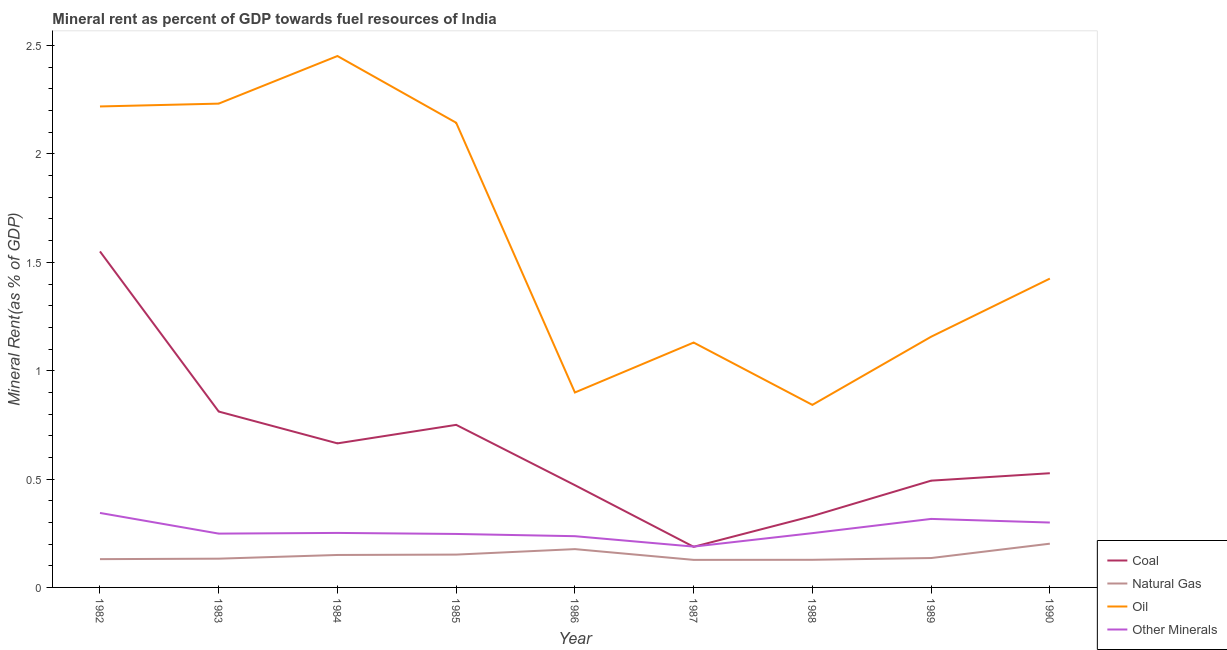How many different coloured lines are there?
Offer a terse response. 4. Is the number of lines equal to the number of legend labels?
Your answer should be compact. Yes. What is the coal rent in 1989?
Provide a short and direct response. 0.49. Across all years, what is the maximum coal rent?
Keep it short and to the point. 1.55. Across all years, what is the minimum coal rent?
Your answer should be compact. 0.19. In which year was the natural gas rent maximum?
Offer a terse response. 1990. In which year was the natural gas rent minimum?
Your answer should be very brief. 1987. What is the total  rent of other minerals in the graph?
Keep it short and to the point. 2.38. What is the difference between the oil rent in 1988 and that in 1989?
Ensure brevity in your answer.  -0.31. What is the difference between the  rent of other minerals in 1985 and the natural gas rent in 1986?
Offer a very short reply. 0.07. What is the average oil rent per year?
Provide a short and direct response. 1.61. In the year 1988, what is the difference between the natural gas rent and  rent of other minerals?
Your response must be concise. -0.12. What is the ratio of the  rent of other minerals in 1986 to that in 1988?
Your answer should be very brief. 0.94. What is the difference between the highest and the second highest oil rent?
Ensure brevity in your answer.  0.22. What is the difference between the highest and the lowest coal rent?
Offer a very short reply. 1.36. In how many years, is the natural gas rent greater than the average natural gas rent taken over all years?
Offer a terse response. 4. Is it the case that in every year, the sum of the  rent of other minerals and oil rent is greater than the sum of coal rent and natural gas rent?
Your answer should be very brief. Yes. Is it the case that in every year, the sum of the coal rent and natural gas rent is greater than the oil rent?
Your answer should be very brief. No. Does the  rent of other minerals monotonically increase over the years?
Your answer should be very brief. No. Is the oil rent strictly greater than the natural gas rent over the years?
Offer a terse response. Yes. Is the natural gas rent strictly less than the coal rent over the years?
Give a very brief answer. Yes. How many lines are there?
Give a very brief answer. 4. Are the values on the major ticks of Y-axis written in scientific E-notation?
Keep it short and to the point. No. How many legend labels are there?
Offer a very short reply. 4. How are the legend labels stacked?
Make the answer very short. Vertical. What is the title of the graph?
Make the answer very short. Mineral rent as percent of GDP towards fuel resources of India. Does "Social Insurance" appear as one of the legend labels in the graph?
Provide a succinct answer. No. What is the label or title of the X-axis?
Provide a succinct answer. Year. What is the label or title of the Y-axis?
Give a very brief answer. Mineral Rent(as % of GDP). What is the Mineral Rent(as % of GDP) in Coal in 1982?
Provide a succinct answer. 1.55. What is the Mineral Rent(as % of GDP) of Natural Gas in 1982?
Your answer should be compact. 0.13. What is the Mineral Rent(as % of GDP) of Oil in 1982?
Your answer should be compact. 2.22. What is the Mineral Rent(as % of GDP) in Other Minerals in 1982?
Provide a succinct answer. 0.34. What is the Mineral Rent(as % of GDP) of Coal in 1983?
Your response must be concise. 0.81. What is the Mineral Rent(as % of GDP) in Natural Gas in 1983?
Your response must be concise. 0.13. What is the Mineral Rent(as % of GDP) of Oil in 1983?
Your response must be concise. 2.23. What is the Mineral Rent(as % of GDP) of Other Minerals in 1983?
Give a very brief answer. 0.25. What is the Mineral Rent(as % of GDP) of Coal in 1984?
Ensure brevity in your answer.  0.66. What is the Mineral Rent(as % of GDP) of Natural Gas in 1984?
Provide a short and direct response. 0.15. What is the Mineral Rent(as % of GDP) in Oil in 1984?
Your answer should be compact. 2.45. What is the Mineral Rent(as % of GDP) in Other Minerals in 1984?
Provide a short and direct response. 0.25. What is the Mineral Rent(as % of GDP) of Coal in 1985?
Your response must be concise. 0.75. What is the Mineral Rent(as % of GDP) in Natural Gas in 1985?
Ensure brevity in your answer.  0.15. What is the Mineral Rent(as % of GDP) of Oil in 1985?
Provide a succinct answer. 2.14. What is the Mineral Rent(as % of GDP) in Other Minerals in 1985?
Make the answer very short. 0.25. What is the Mineral Rent(as % of GDP) in Coal in 1986?
Provide a short and direct response. 0.47. What is the Mineral Rent(as % of GDP) of Natural Gas in 1986?
Your response must be concise. 0.18. What is the Mineral Rent(as % of GDP) of Oil in 1986?
Provide a succinct answer. 0.9. What is the Mineral Rent(as % of GDP) in Other Minerals in 1986?
Give a very brief answer. 0.24. What is the Mineral Rent(as % of GDP) of Coal in 1987?
Keep it short and to the point. 0.19. What is the Mineral Rent(as % of GDP) of Natural Gas in 1987?
Provide a short and direct response. 0.13. What is the Mineral Rent(as % of GDP) in Oil in 1987?
Offer a terse response. 1.13. What is the Mineral Rent(as % of GDP) in Other Minerals in 1987?
Make the answer very short. 0.19. What is the Mineral Rent(as % of GDP) in Coal in 1988?
Offer a terse response. 0.33. What is the Mineral Rent(as % of GDP) in Natural Gas in 1988?
Provide a succinct answer. 0.13. What is the Mineral Rent(as % of GDP) in Oil in 1988?
Your answer should be compact. 0.84. What is the Mineral Rent(as % of GDP) in Other Minerals in 1988?
Offer a very short reply. 0.25. What is the Mineral Rent(as % of GDP) of Coal in 1989?
Ensure brevity in your answer.  0.49. What is the Mineral Rent(as % of GDP) of Natural Gas in 1989?
Give a very brief answer. 0.14. What is the Mineral Rent(as % of GDP) of Oil in 1989?
Your answer should be compact. 1.16. What is the Mineral Rent(as % of GDP) of Other Minerals in 1989?
Your answer should be compact. 0.32. What is the Mineral Rent(as % of GDP) of Coal in 1990?
Give a very brief answer. 0.53. What is the Mineral Rent(as % of GDP) of Natural Gas in 1990?
Provide a succinct answer. 0.2. What is the Mineral Rent(as % of GDP) in Oil in 1990?
Ensure brevity in your answer.  1.42. What is the Mineral Rent(as % of GDP) of Other Minerals in 1990?
Provide a succinct answer. 0.3. Across all years, what is the maximum Mineral Rent(as % of GDP) of Coal?
Offer a very short reply. 1.55. Across all years, what is the maximum Mineral Rent(as % of GDP) in Natural Gas?
Offer a terse response. 0.2. Across all years, what is the maximum Mineral Rent(as % of GDP) in Oil?
Offer a terse response. 2.45. Across all years, what is the maximum Mineral Rent(as % of GDP) in Other Minerals?
Ensure brevity in your answer.  0.34. Across all years, what is the minimum Mineral Rent(as % of GDP) of Coal?
Your answer should be very brief. 0.19. Across all years, what is the minimum Mineral Rent(as % of GDP) in Natural Gas?
Give a very brief answer. 0.13. Across all years, what is the minimum Mineral Rent(as % of GDP) of Oil?
Provide a succinct answer. 0.84. Across all years, what is the minimum Mineral Rent(as % of GDP) in Other Minerals?
Offer a terse response. 0.19. What is the total Mineral Rent(as % of GDP) in Coal in the graph?
Your answer should be very brief. 5.78. What is the total Mineral Rent(as % of GDP) in Natural Gas in the graph?
Provide a short and direct response. 1.33. What is the total Mineral Rent(as % of GDP) of Oil in the graph?
Ensure brevity in your answer.  14.5. What is the total Mineral Rent(as % of GDP) in Other Minerals in the graph?
Your response must be concise. 2.38. What is the difference between the Mineral Rent(as % of GDP) of Coal in 1982 and that in 1983?
Provide a succinct answer. 0.74. What is the difference between the Mineral Rent(as % of GDP) in Natural Gas in 1982 and that in 1983?
Your answer should be very brief. -0. What is the difference between the Mineral Rent(as % of GDP) in Oil in 1982 and that in 1983?
Your answer should be very brief. -0.01. What is the difference between the Mineral Rent(as % of GDP) in Other Minerals in 1982 and that in 1983?
Give a very brief answer. 0.1. What is the difference between the Mineral Rent(as % of GDP) of Coal in 1982 and that in 1984?
Provide a short and direct response. 0.89. What is the difference between the Mineral Rent(as % of GDP) in Natural Gas in 1982 and that in 1984?
Offer a very short reply. -0.02. What is the difference between the Mineral Rent(as % of GDP) of Oil in 1982 and that in 1984?
Provide a succinct answer. -0.23. What is the difference between the Mineral Rent(as % of GDP) in Other Minerals in 1982 and that in 1984?
Offer a very short reply. 0.09. What is the difference between the Mineral Rent(as % of GDP) of Coal in 1982 and that in 1985?
Provide a short and direct response. 0.8. What is the difference between the Mineral Rent(as % of GDP) of Natural Gas in 1982 and that in 1985?
Ensure brevity in your answer.  -0.02. What is the difference between the Mineral Rent(as % of GDP) in Oil in 1982 and that in 1985?
Offer a terse response. 0.08. What is the difference between the Mineral Rent(as % of GDP) of Other Minerals in 1982 and that in 1985?
Give a very brief answer. 0.1. What is the difference between the Mineral Rent(as % of GDP) in Coal in 1982 and that in 1986?
Keep it short and to the point. 1.08. What is the difference between the Mineral Rent(as % of GDP) of Natural Gas in 1982 and that in 1986?
Ensure brevity in your answer.  -0.05. What is the difference between the Mineral Rent(as % of GDP) of Oil in 1982 and that in 1986?
Make the answer very short. 1.32. What is the difference between the Mineral Rent(as % of GDP) of Other Minerals in 1982 and that in 1986?
Ensure brevity in your answer.  0.11. What is the difference between the Mineral Rent(as % of GDP) of Coal in 1982 and that in 1987?
Your answer should be compact. 1.36. What is the difference between the Mineral Rent(as % of GDP) in Natural Gas in 1982 and that in 1987?
Keep it short and to the point. 0. What is the difference between the Mineral Rent(as % of GDP) of Oil in 1982 and that in 1987?
Make the answer very short. 1.09. What is the difference between the Mineral Rent(as % of GDP) in Other Minerals in 1982 and that in 1987?
Your response must be concise. 0.16. What is the difference between the Mineral Rent(as % of GDP) in Coal in 1982 and that in 1988?
Make the answer very short. 1.22. What is the difference between the Mineral Rent(as % of GDP) of Natural Gas in 1982 and that in 1988?
Give a very brief answer. 0. What is the difference between the Mineral Rent(as % of GDP) in Oil in 1982 and that in 1988?
Your answer should be compact. 1.38. What is the difference between the Mineral Rent(as % of GDP) in Other Minerals in 1982 and that in 1988?
Offer a very short reply. 0.09. What is the difference between the Mineral Rent(as % of GDP) in Coal in 1982 and that in 1989?
Your answer should be compact. 1.06. What is the difference between the Mineral Rent(as % of GDP) in Natural Gas in 1982 and that in 1989?
Ensure brevity in your answer.  -0.01. What is the difference between the Mineral Rent(as % of GDP) in Oil in 1982 and that in 1989?
Provide a short and direct response. 1.06. What is the difference between the Mineral Rent(as % of GDP) in Other Minerals in 1982 and that in 1989?
Offer a very short reply. 0.03. What is the difference between the Mineral Rent(as % of GDP) of Coal in 1982 and that in 1990?
Make the answer very short. 1.02. What is the difference between the Mineral Rent(as % of GDP) of Natural Gas in 1982 and that in 1990?
Your response must be concise. -0.07. What is the difference between the Mineral Rent(as % of GDP) in Oil in 1982 and that in 1990?
Give a very brief answer. 0.79. What is the difference between the Mineral Rent(as % of GDP) in Other Minerals in 1982 and that in 1990?
Offer a very short reply. 0.04. What is the difference between the Mineral Rent(as % of GDP) of Coal in 1983 and that in 1984?
Give a very brief answer. 0.15. What is the difference between the Mineral Rent(as % of GDP) of Natural Gas in 1983 and that in 1984?
Provide a succinct answer. -0.02. What is the difference between the Mineral Rent(as % of GDP) in Oil in 1983 and that in 1984?
Your response must be concise. -0.22. What is the difference between the Mineral Rent(as % of GDP) of Other Minerals in 1983 and that in 1984?
Your answer should be very brief. -0. What is the difference between the Mineral Rent(as % of GDP) in Coal in 1983 and that in 1985?
Keep it short and to the point. 0.06. What is the difference between the Mineral Rent(as % of GDP) of Natural Gas in 1983 and that in 1985?
Your answer should be very brief. -0.02. What is the difference between the Mineral Rent(as % of GDP) of Oil in 1983 and that in 1985?
Ensure brevity in your answer.  0.09. What is the difference between the Mineral Rent(as % of GDP) in Other Minerals in 1983 and that in 1985?
Provide a succinct answer. 0. What is the difference between the Mineral Rent(as % of GDP) in Coal in 1983 and that in 1986?
Your answer should be very brief. 0.34. What is the difference between the Mineral Rent(as % of GDP) of Natural Gas in 1983 and that in 1986?
Provide a succinct answer. -0.04. What is the difference between the Mineral Rent(as % of GDP) of Oil in 1983 and that in 1986?
Your response must be concise. 1.33. What is the difference between the Mineral Rent(as % of GDP) in Other Minerals in 1983 and that in 1986?
Make the answer very short. 0.01. What is the difference between the Mineral Rent(as % of GDP) of Coal in 1983 and that in 1987?
Your response must be concise. 0.62. What is the difference between the Mineral Rent(as % of GDP) of Natural Gas in 1983 and that in 1987?
Provide a succinct answer. 0.01. What is the difference between the Mineral Rent(as % of GDP) of Oil in 1983 and that in 1987?
Offer a terse response. 1.1. What is the difference between the Mineral Rent(as % of GDP) of Other Minerals in 1983 and that in 1987?
Your answer should be compact. 0.06. What is the difference between the Mineral Rent(as % of GDP) of Coal in 1983 and that in 1988?
Keep it short and to the point. 0.48. What is the difference between the Mineral Rent(as % of GDP) of Natural Gas in 1983 and that in 1988?
Ensure brevity in your answer.  0.01. What is the difference between the Mineral Rent(as % of GDP) of Oil in 1983 and that in 1988?
Provide a succinct answer. 1.39. What is the difference between the Mineral Rent(as % of GDP) in Other Minerals in 1983 and that in 1988?
Keep it short and to the point. -0. What is the difference between the Mineral Rent(as % of GDP) of Coal in 1983 and that in 1989?
Provide a short and direct response. 0.32. What is the difference between the Mineral Rent(as % of GDP) in Natural Gas in 1983 and that in 1989?
Provide a succinct answer. -0. What is the difference between the Mineral Rent(as % of GDP) in Oil in 1983 and that in 1989?
Keep it short and to the point. 1.08. What is the difference between the Mineral Rent(as % of GDP) of Other Minerals in 1983 and that in 1989?
Offer a terse response. -0.07. What is the difference between the Mineral Rent(as % of GDP) in Coal in 1983 and that in 1990?
Ensure brevity in your answer.  0.28. What is the difference between the Mineral Rent(as % of GDP) of Natural Gas in 1983 and that in 1990?
Provide a succinct answer. -0.07. What is the difference between the Mineral Rent(as % of GDP) of Oil in 1983 and that in 1990?
Your response must be concise. 0.81. What is the difference between the Mineral Rent(as % of GDP) in Other Minerals in 1983 and that in 1990?
Your response must be concise. -0.05. What is the difference between the Mineral Rent(as % of GDP) of Coal in 1984 and that in 1985?
Offer a very short reply. -0.09. What is the difference between the Mineral Rent(as % of GDP) of Natural Gas in 1984 and that in 1985?
Provide a short and direct response. -0. What is the difference between the Mineral Rent(as % of GDP) in Oil in 1984 and that in 1985?
Your answer should be very brief. 0.31. What is the difference between the Mineral Rent(as % of GDP) in Other Minerals in 1984 and that in 1985?
Your response must be concise. 0. What is the difference between the Mineral Rent(as % of GDP) of Coal in 1984 and that in 1986?
Give a very brief answer. 0.19. What is the difference between the Mineral Rent(as % of GDP) in Natural Gas in 1984 and that in 1986?
Your response must be concise. -0.03. What is the difference between the Mineral Rent(as % of GDP) in Oil in 1984 and that in 1986?
Provide a short and direct response. 1.55. What is the difference between the Mineral Rent(as % of GDP) of Other Minerals in 1984 and that in 1986?
Ensure brevity in your answer.  0.02. What is the difference between the Mineral Rent(as % of GDP) of Coal in 1984 and that in 1987?
Provide a succinct answer. 0.48. What is the difference between the Mineral Rent(as % of GDP) of Natural Gas in 1984 and that in 1987?
Provide a succinct answer. 0.02. What is the difference between the Mineral Rent(as % of GDP) of Oil in 1984 and that in 1987?
Your answer should be compact. 1.32. What is the difference between the Mineral Rent(as % of GDP) of Other Minerals in 1984 and that in 1987?
Your response must be concise. 0.06. What is the difference between the Mineral Rent(as % of GDP) of Coal in 1984 and that in 1988?
Offer a very short reply. 0.34. What is the difference between the Mineral Rent(as % of GDP) in Natural Gas in 1984 and that in 1988?
Give a very brief answer. 0.02. What is the difference between the Mineral Rent(as % of GDP) of Oil in 1984 and that in 1988?
Ensure brevity in your answer.  1.61. What is the difference between the Mineral Rent(as % of GDP) of Other Minerals in 1984 and that in 1988?
Provide a short and direct response. 0. What is the difference between the Mineral Rent(as % of GDP) of Coal in 1984 and that in 1989?
Your answer should be compact. 0.17. What is the difference between the Mineral Rent(as % of GDP) in Natural Gas in 1984 and that in 1989?
Keep it short and to the point. 0.01. What is the difference between the Mineral Rent(as % of GDP) in Oil in 1984 and that in 1989?
Give a very brief answer. 1.3. What is the difference between the Mineral Rent(as % of GDP) of Other Minerals in 1984 and that in 1989?
Your answer should be compact. -0.06. What is the difference between the Mineral Rent(as % of GDP) of Coal in 1984 and that in 1990?
Your response must be concise. 0.14. What is the difference between the Mineral Rent(as % of GDP) of Natural Gas in 1984 and that in 1990?
Provide a short and direct response. -0.05. What is the difference between the Mineral Rent(as % of GDP) of Oil in 1984 and that in 1990?
Keep it short and to the point. 1.03. What is the difference between the Mineral Rent(as % of GDP) of Other Minerals in 1984 and that in 1990?
Your response must be concise. -0.05. What is the difference between the Mineral Rent(as % of GDP) in Coal in 1985 and that in 1986?
Your answer should be compact. 0.28. What is the difference between the Mineral Rent(as % of GDP) in Natural Gas in 1985 and that in 1986?
Make the answer very short. -0.03. What is the difference between the Mineral Rent(as % of GDP) in Oil in 1985 and that in 1986?
Give a very brief answer. 1.24. What is the difference between the Mineral Rent(as % of GDP) of Other Minerals in 1985 and that in 1986?
Provide a succinct answer. 0.01. What is the difference between the Mineral Rent(as % of GDP) in Coal in 1985 and that in 1987?
Provide a succinct answer. 0.56. What is the difference between the Mineral Rent(as % of GDP) in Natural Gas in 1985 and that in 1987?
Provide a short and direct response. 0.02. What is the difference between the Mineral Rent(as % of GDP) of Oil in 1985 and that in 1987?
Provide a succinct answer. 1.01. What is the difference between the Mineral Rent(as % of GDP) in Other Minerals in 1985 and that in 1987?
Provide a short and direct response. 0.06. What is the difference between the Mineral Rent(as % of GDP) of Coal in 1985 and that in 1988?
Your answer should be very brief. 0.42. What is the difference between the Mineral Rent(as % of GDP) of Natural Gas in 1985 and that in 1988?
Give a very brief answer. 0.02. What is the difference between the Mineral Rent(as % of GDP) in Oil in 1985 and that in 1988?
Make the answer very short. 1.3. What is the difference between the Mineral Rent(as % of GDP) in Other Minerals in 1985 and that in 1988?
Offer a terse response. -0. What is the difference between the Mineral Rent(as % of GDP) in Coal in 1985 and that in 1989?
Offer a terse response. 0.26. What is the difference between the Mineral Rent(as % of GDP) of Natural Gas in 1985 and that in 1989?
Offer a very short reply. 0.02. What is the difference between the Mineral Rent(as % of GDP) in Oil in 1985 and that in 1989?
Your response must be concise. 0.99. What is the difference between the Mineral Rent(as % of GDP) of Other Minerals in 1985 and that in 1989?
Keep it short and to the point. -0.07. What is the difference between the Mineral Rent(as % of GDP) of Coal in 1985 and that in 1990?
Provide a short and direct response. 0.22. What is the difference between the Mineral Rent(as % of GDP) in Natural Gas in 1985 and that in 1990?
Keep it short and to the point. -0.05. What is the difference between the Mineral Rent(as % of GDP) of Oil in 1985 and that in 1990?
Make the answer very short. 0.72. What is the difference between the Mineral Rent(as % of GDP) in Other Minerals in 1985 and that in 1990?
Provide a short and direct response. -0.05. What is the difference between the Mineral Rent(as % of GDP) of Coal in 1986 and that in 1987?
Provide a succinct answer. 0.28. What is the difference between the Mineral Rent(as % of GDP) of Natural Gas in 1986 and that in 1987?
Give a very brief answer. 0.05. What is the difference between the Mineral Rent(as % of GDP) in Oil in 1986 and that in 1987?
Provide a succinct answer. -0.23. What is the difference between the Mineral Rent(as % of GDP) in Other Minerals in 1986 and that in 1987?
Provide a succinct answer. 0.05. What is the difference between the Mineral Rent(as % of GDP) in Coal in 1986 and that in 1988?
Provide a succinct answer. 0.14. What is the difference between the Mineral Rent(as % of GDP) of Natural Gas in 1986 and that in 1988?
Offer a very short reply. 0.05. What is the difference between the Mineral Rent(as % of GDP) of Oil in 1986 and that in 1988?
Keep it short and to the point. 0.06. What is the difference between the Mineral Rent(as % of GDP) in Other Minerals in 1986 and that in 1988?
Provide a succinct answer. -0.01. What is the difference between the Mineral Rent(as % of GDP) in Coal in 1986 and that in 1989?
Your response must be concise. -0.02. What is the difference between the Mineral Rent(as % of GDP) of Natural Gas in 1986 and that in 1989?
Your answer should be very brief. 0.04. What is the difference between the Mineral Rent(as % of GDP) in Oil in 1986 and that in 1989?
Offer a terse response. -0.26. What is the difference between the Mineral Rent(as % of GDP) of Other Minerals in 1986 and that in 1989?
Your response must be concise. -0.08. What is the difference between the Mineral Rent(as % of GDP) in Coal in 1986 and that in 1990?
Give a very brief answer. -0.06. What is the difference between the Mineral Rent(as % of GDP) of Natural Gas in 1986 and that in 1990?
Give a very brief answer. -0.03. What is the difference between the Mineral Rent(as % of GDP) of Oil in 1986 and that in 1990?
Offer a terse response. -0.53. What is the difference between the Mineral Rent(as % of GDP) of Other Minerals in 1986 and that in 1990?
Your answer should be very brief. -0.06. What is the difference between the Mineral Rent(as % of GDP) of Coal in 1987 and that in 1988?
Make the answer very short. -0.14. What is the difference between the Mineral Rent(as % of GDP) of Natural Gas in 1987 and that in 1988?
Offer a very short reply. -0. What is the difference between the Mineral Rent(as % of GDP) of Oil in 1987 and that in 1988?
Your answer should be compact. 0.29. What is the difference between the Mineral Rent(as % of GDP) of Other Minerals in 1987 and that in 1988?
Your answer should be very brief. -0.06. What is the difference between the Mineral Rent(as % of GDP) in Coal in 1987 and that in 1989?
Give a very brief answer. -0.31. What is the difference between the Mineral Rent(as % of GDP) of Natural Gas in 1987 and that in 1989?
Offer a terse response. -0.01. What is the difference between the Mineral Rent(as % of GDP) in Oil in 1987 and that in 1989?
Your answer should be very brief. -0.03. What is the difference between the Mineral Rent(as % of GDP) in Other Minerals in 1987 and that in 1989?
Offer a terse response. -0.13. What is the difference between the Mineral Rent(as % of GDP) of Coal in 1987 and that in 1990?
Your answer should be very brief. -0.34. What is the difference between the Mineral Rent(as % of GDP) of Natural Gas in 1987 and that in 1990?
Offer a very short reply. -0.07. What is the difference between the Mineral Rent(as % of GDP) in Oil in 1987 and that in 1990?
Give a very brief answer. -0.3. What is the difference between the Mineral Rent(as % of GDP) of Other Minerals in 1987 and that in 1990?
Ensure brevity in your answer.  -0.11. What is the difference between the Mineral Rent(as % of GDP) of Coal in 1988 and that in 1989?
Give a very brief answer. -0.16. What is the difference between the Mineral Rent(as % of GDP) in Natural Gas in 1988 and that in 1989?
Ensure brevity in your answer.  -0.01. What is the difference between the Mineral Rent(as % of GDP) of Oil in 1988 and that in 1989?
Give a very brief answer. -0.31. What is the difference between the Mineral Rent(as % of GDP) in Other Minerals in 1988 and that in 1989?
Your answer should be very brief. -0.07. What is the difference between the Mineral Rent(as % of GDP) in Coal in 1988 and that in 1990?
Give a very brief answer. -0.2. What is the difference between the Mineral Rent(as % of GDP) of Natural Gas in 1988 and that in 1990?
Keep it short and to the point. -0.07. What is the difference between the Mineral Rent(as % of GDP) of Oil in 1988 and that in 1990?
Your answer should be very brief. -0.58. What is the difference between the Mineral Rent(as % of GDP) of Other Minerals in 1988 and that in 1990?
Keep it short and to the point. -0.05. What is the difference between the Mineral Rent(as % of GDP) of Coal in 1989 and that in 1990?
Provide a succinct answer. -0.03. What is the difference between the Mineral Rent(as % of GDP) in Natural Gas in 1989 and that in 1990?
Ensure brevity in your answer.  -0.07. What is the difference between the Mineral Rent(as % of GDP) of Oil in 1989 and that in 1990?
Offer a very short reply. -0.27. What is the difference between the Mineral Rent(as % of GDP) in Other Minerals in 1989 and that in 1990?
Give a very brief answer. 0.02. What is the difference between the Mineral Rent(as % of GDP) in Coal in 1982 and the Mineral Rent(as % of GDP) in Natural Gas in 1983?
Provide a succinct answer. 1.42. What is the difference between the Mineral Rent(as % of GDP) of Coal in 1982 and the Mineral Rent(as % of GDP) of Oil in 1983?
Your answer should be very brief. -0.68. What is the difference between the Mineral Rent(as % of GDP) in Coal in 1982 and the Mineral Rent(as % of GDP) in Other Minerals in 1983?
Offer a very short reply. 1.3. What is the difference between the Mineral Rent(as % of GDP) of Natural Gas in 1982 and the Mineral Rent(as % of GDP) of Oil in 1983?
Your response must be concise. -2.1. What is the difference between the Mineral Rent(as % of GDP) of Natural Gas in 1982 and the Mineral Rent(as % of GDP) of Other Minerals in 1983?
Your response must be concise. -0.12. What is the difference between the Mineral Rent(as % of GDP) of Oil in 1982 and the Mineral Rent(as % of GDP) of Other Minerals in 1983?
Provide a short and direct response. 1.97. What is the difference between the Mineral Rent(as % of GDP) in Coal in 1982 and the Mineral Rent(as % of GDP) in Natural Gas in 1984?
Offer a very short reply. 1.4. What is the difference between the Mineral Rent(as % of GDP) in Coal in 1982 and the Mineral Rent(as % of GDP) in Oil in 1984?
Offer a terse response. -0.9. What is the difference between the Mineral Rent(as % of GDP) in Coal in 1982 and the Mineral Rent(as % of GDP) in Other Minerals in 1984?
Your response must be concise. 1.3. What is the difference between the Mineral Rent(as % of GDP) of Natural Gas in 1982 and the Mineral Rent(as % of GDP) of Oil in 1984?
Your answer should be compact. -2.32. What is the difference between the Mineral Rent(as % of GDP) of Natural Gas in 1982 and the Mineral Rent(as % of GDP) of Other Minerals in 1984?
Give a very brief answer. -0.12. What is the difference between the Mineral Rent(as % of GDP) of Oil in 1982 and the Mineral Rent(as % of GDP) of Other Minerals in 1984?
Give a very brief answer. 1.97. What is the difference between the Mineral Rent(as % of GDP) of Coal in 1982 and the Mineral Rent(as % of GDP) of Natural Gas in 1985?
Provide a short and direct response. 1.4. What is the difference between the Mineral Rent(as % of GDP) in Coal in 1982 and the Mineral Rent(as % of GDP) in Oil in 1985?
Give a very brief answer. -0.59. What is the difference between the Mineral Rent(as % of GDP) of Coal in 1982 and the Mineral Rent(as % of GDP) of Other Minerals in 1985?
Offer a terse response. 1.3. What is the difference between the Mineral Rent(as % of GDP) of Natural Gas in 1982 and the Mineral Rent(as % of GDP) of Oil in 1985?
Ensure brevity in your answer.  -2.01. What is the difference between the Mineral Rent(as % of GDP) of Natural Gas in 1982 and the Mineral Rent(as % of GDP) of Other Minerals in 1985?
Offer a terse response. -0.12. What is the difference between the Mineral Rent(as % of GDP) in Oil in 1982 and the Mineral Rent(as % of GDP) in Other Minerals in 1985?
Your answer should be compact. 1.97. What is the difference between the Mineral Rent(as % of GDP) in Coal in 1982 and the Mineral Rent(as % of GDP) in Natural Gas in 1986?
Provide a succinct answer. 1.37. What is the difference between the Mineral Rent(as % of GDP) in Coal in 1982 and the Mineral Rent(as % of GDP) in Oil in 1986?
Keep it short and to the point. 0.65. What is the difference between the Mineral Rent(as % of GDP) in Coal in 1982 and the Mineral Rent(as % of GDP) in Other Minerals in 1986?
Ensure brevity in your answer.  1.31. What is the difference between the Mineral Rent(as % of GDP) of Natural Gas in 1982 and the Mineral Rent(as % of GDP) of Oil in 1986?
Keep it short and to the point. -0.77. What is the difference between the Mineral Rent(as % of GDP) in Natural Gas in 1982 and the Mineral Rent(as % of GDP) in Other Minerals in 1986?
Offer a terse response. -0.11. What is the difference between the Mineral Rent(as % of GDP) of Oil in 1982 and the Mineral Rent(as % of GDP) of Other Minerals in 1986?
Ensure brevity in your answer.  1.98. What is the difference between the Mineral Rent(as % of GDP) of Coal in 1982 and the Mineral Rent(as % of GDP) of Natural Gas in 1987?
Provide a short and direct response. 1.42. What is the difference between the Mineral Rent(as % of GDP) in Coal in 1982 and the Mineral Rent(as % of GDP) in Oil in 1987?
Your answer should be compact. 0.42. What is the difference between the Mineral Rent(as % of GDP) of Coal in 1982 and the Mineral Rent(as % of GDP) of Other Minerals in 1987?
Provide a succinct answer. 1.36. What is the difference between the Mineral Rent(as % of GDP) of Natural Gas in 1982 and the Mineral Rent(as % of GDP) of Oil in 1987?
Your answer should be compact. -1. What is the difference between the Mineral Rent(as % of GDP) of Natural Gas in 1982 and the Mineral Rent(as % of GDP) of Other Minerals in 1987?
Make the answer very short. -0.06. What is the difference between the Mineral Rent(as % of GDP) in Oil in 1982 and the Mineral Rent(as % of GDP) in Other Minerals in 1987?
Provide a succinct answer. 2.03. What is the difference between the Mineral Rent(as % of GDP) in Coal in 1982 and the Mineral Rent(as % of GDP) in Natural Gas in 1988?
Your answer should be very brief. 1.42. What is the difference between the Mineral Rent(as % of GDP) in Coal in 1982 and the Mineral Rent(as % of GDP) in Oil in 1988?
Ensure brevity in your answer.  0.71. What is the difference between the Mineral Rent(as % of GDP) in Coal in 1982 and the Mineral Rent(as % of GDP) in Other Minerals in 1988?
Provide a short and direct response. 1.3. What is the difference between the Mineral Rent(as % of GDP) of Natural Gas in 1982 and the Mineral Rent(as % of GDP) of Oil in 1988?
Your response must be concise. -0.71. What is the difference between the Mineral Rent(as % of GDP) in Natural Gas in 1982 and the Mineral Rent(as % of GDP) in Other Minerals in 1988?
Offer a very short reply. -0.12. What is the difference between the Mineral Rent(as % of GDP) in Oil in 1982 and the Mineral Rent(as % of GDP) in Other Minerals in 1988?
Give a very brief answer. 1.97. What is the difference between the Mineral Rent(as % of GDP) in Coal in 1982 and the Mineral Rent(as % of GDP) in Natural Gas in 1989?
Your response must be concise. 1.41. What is the difference between the Mineral Rent(as % of GDP) of Coal in 1982 and the Mineral Rent(as % of GDP) of Oil in 1989?
Offer a very short reply. 0.39. What is the difference between the Mineral Rent(as % of GDP) in Coal in 1982 and the Mineral Rent(as % of GDP) in Other Minerals in 1989?
Offer a very short reply. 1.23. What is the difference between the Mineral Rent(as % of GDP) in Natural Gas in 1982 and the Mineral Rent(as % of GDP) in Oil in 1989?
Offer a very short reply. -1.03. What is the difference between the Mineral Rent(as % of GDP) of Natural Gas in 1982 and the Mineral Rent(as % of GDP) of Other Minerals in 1989?
Offer a terse response. -0.19. What is the difference between the Mineral Rent(as % of GDP) of Oil in 1982 and the Mineral Rent(as % of GDP) of Other Minerals in 1989?
Make the answer very short. 1.9. What is the difference between the Mineral Rent(as % of GDP) of Coal in 1982 and the Mineral Rent(as % of GDP) of Natural Gas in 1990?
Your answer should be very brief. 1.35. What is the difference between the Mineral Rent(as % of GDP) of Coal in 1982 and the Mineral Rent(as % of GDP) of Oil in 1990?
Your response must be concise. 0.13. What is the difference between the Mineral Rent(as % of GDP) of Coal in 1982 and the Mineral Rent(as % of GDP) of Other Minerals in 1990?
Ensure brevity in your answer.  1.25. What is the difference between the Mineral Rent(as % of GDP) in Natural Gas in 1982 and the Mineral Rent(as % of GDP) in Oil in 1990?
Keep it short and to the point. -1.29. What is the difference between the Mineral Rent(as % of GDP) in Natural Gas in 1982 and the Mineral Rent(as % of GDP) in Other Minerals in 1990?
Give a very brief answer. -0.17. What is the difference between the Mineral Rent(as % of GDP) of Oil in 1982 and the Mineral Rent(as % of GDP) of Other Minerals in 1990?
Give a very brief answer. 1.92. What is the difference between the Mineral Rent(as % of GDP) of Coal in 1983 and the Mineral Rent(as % of GDP) of Natural Gas in 1984?
Offer a very short reply. 0.66. What is the difference between the Mineral Rent(as % of GDP) in Coal in 1983 and the Mineral Rent(as % of GDP) in Oil in 1984?
Provide a short and direct response. -1.64. What is the difference between the Mineral Rent(as % of GDP) in Coal in 1983 and the Mineral Rent(as % of GDP) in Other Minerals in 1984?
Provide a succinct answer. 0.56. What is the difference between the Mineral Rent(as % of GDP) of Natural Gas in 1983 and the Mineral Rent(as % of GDP) of Oil in 1984?
Offer a very short reply. -2.32. What is the difference between the Mineral Rent(as % of GDP) of Natural Gas in 1983 and the Mineral Rent(as % of GDP) of Other Minerals in 1984?
Your answer should be very brief. -0.12. What is the difference between the Mineral Rent(as % of GDP) of Oil in 1983 and the Mineral Rent(as % of GDP) of Other Minerals in 1984?
Offer a terse response. 1.98. What is the difference between the Mineral Rent(as % of GDP) in Coal in 1983 and the Mineral Rent(as % of GDP) in Natural Gas in 1985?
Provide a succinct answer. 0.66. What is the difference between the Mineral Rent(as % of GDP) in Coal in 1983 and the Mineral Rent(as % of GDP) in Oil in 1985?
Ensure brevity in your answer.  -1.33. What is the difference between the Mineral Rent(as % of GDP) of Coal in 1983 and the Mineral Rent(as % of GDP) of Other Minerals in 1985?
Provide a short and direct response. 0.56. What is the difference between the Mineral Rent(as % of GDP) in Natural Gas in 1983 and the Mineral Rent(as % of GDP) in Oil in 1985?
Keep it short and to the point. -2.01. What is the difference between the Mineral Rent(as % of GDP) of Natural Gas in 1983 and the Mineral Rent(as % of GDP) of Other Minerals in 1985?
Offer a terse response. -0.11. What is the difference between the Mineral Rent(as % of GDP) of Oil in 1983 and the Mineral Rent(as % of GDP) of Other Minerals in 1985?
Provide a short and direct response. 1.99. What is the difference between the Mineral Rent(as % of GDP) in Coal in 1983 and the Mineral Rent(as % of GDP) in Natural Gas in 1986?
Offer a terse response. 0.63. What is the difference between the Mineral Rent(as % of GDP) in Coal in 1983 and the Mineral Rent(as % of GDP) in Oil in 1986?
Provide a short and direct response. -0.09. What is the difference between the Mineral Rent(as % of GDP) of Coal in 1983 and the Mineral Rent(as % of GDP) of Other Minerals in 1986?
Keep it short and to the point. 0.58. What is the difference between the Mineral Rent(as % of GDP) in Natural Gas in 1983 and the Mineral Rent(as % of GDP) in Oil in 1986?
Your response must be concise. -0.77. What is the difference between the Mineral Rent(as % of GDP) in Natural Gas in 1983 and the Mineral Rent(as % of GDP) in Other Minerals in 1986?
Your answer should be very brief. -0.1. What is the difference between the Mineral Rent(as % of GDP) in Oil in 1983 and the Mineral Rent(as % of GDP) in Other Minerals in 1986?
Ensure brevity in your answer.  2. What is the difference between the Mineral Rent(as % of GDP) in Coal in 1983 and the Mineral Rent(as % of GDP) in Natural Gas in 1987?
Ensure brevity in your answer.  0.68. What is the difference between the Mineral Rent(as % of GDP) in Coal in 1983 and the Mineral Rent(as % of GDP) in Oil in 1987?
Ensure brevity in your answer.  -0.32. What is the difference between the Mineral Rent(as % of GDP) of Coal in 1983 and the Mineral Rent(as % of GDP) of Other Minerals in 1987?
Make the answer very short. 0.62. What is the difference between the Mineral Rent(as % of GDP) in Natural Gas in 1983 and the Mineral Rent(as % of GDP) in Oil in 1987?
Make the answer very short. -1. What is the difference between the Mineral Rent(as % of GDP) of Natural Gas in 1983 and the Mineral Rent(as % of GDP) of Other Minerals in 1987?
Provide a succinct answer. -0.06. What is the difference between the Mineral Rent(as % of GDP) in Oil in 1983 and the Mineral Rent(as % of GDP) in Other Minerals in 1987?
Your answer should be very brief. 2.04. What is the difference between the Mineral Rent(as % of GDP) in Coal in 1983 and the Mineral Rent(as % of GDP) in Natural Gas in 1988?
Your response must be concise. 0.68. What is the difference between the Mineral Rent(as % of GDP) of Coal in 1983 and the Mineral Rent(as % of GDP) of Oil in 1988?
Your answer should be compact. -0.03. What is the difference between the Mineral Rent(as % of GDP) of Coal in 1983 and the Mineral Rent(as % of GDP) of Other Minerals in 1988?
Your response must be concise. 0.56. What is the difference between the Mineral Rent(as % of GDP) in Natural Gas in 1983 and the Mineral Rent(as % of GDP) in Oil in 1988?
Offer a terse response. -0.71. What is the difference between the Mineral Rent(as % of GDP) of Natural Gas in 1983 and the Mineral Rent(as % of GDP) of Other Minerals in 1988?
Your answer should be compact. -0.12. What is the difference between the Mineral Rent(as % of GDP) of Oil in 1983 and the Mineral Rent(as % of GDP) of Other Minerals in 1988?
Your response must be concise. 1.98. What is the difference between the Mineral Rent(as % of GDP) in Coal in 1983 and the Mineral Rent(as % of GDP) in Natural Gas in 1989?
Offer a terse response. 0.68. What is the difference between the Mineral Rent(as % of GDP) of Coal in 1983 and the Mineral Rent(as % of GDP) of Oil in 1989?
Make the answer very short. -0.35. What is the difference between the Mineral Rent(as % of GDP) of Coal in 1983 and the Mineral Rent(as % of GDP) of Other Minerals in 1989?
Provide a short and direct response. 0.5. What is the difference between the Mineral Rent(as % of GDP) of Natural Gas in 1983 and the Mineral Rent(as % of GDP) of Oil in 1989?
Your answer should be very brief. -1.02. What is the difference between the Mineral Rent(as % of GDP) in Natural Gas in 1983 and the Mineral Rent(as % of GDP) in Other Minerals in 1989?
Your response must be concise. -0.18. What is the difference between the Mineral Rent(as % of GDP) of Oil in 1983 and the Mineral Rent(as % of GDP) of Other Minerals in 1989?
Your answer should be compact. 1.92. What is the difference between the Mineral Rent(as % of GDP) of Coal in 1983 and the Mineral Rent(as % of GDP) of Natural Gas in 1990?
Provide a short and direct response. 0.61. What is the difference between the Mineral Rent(as % of GDP) in Coal in 1983 and the Mineral Rent(as % of GDP) in Oil in 1990?
Offer a very short reply. -0.61. What is the difference between the Mineral Rent(as % of GDP) in Coal in 1983 and the Mineral Rent(as % of GDP) in Other Minerals in 1990?
Give a very brief answer. 0.51. What is the difference between the Mineral Rent(as % of GDP) of Natural Gas in 1983 and the Mineral Rent(as % of GDP) of Oil in 1990?
Provide a succinct answer. -1.29. What is the difference between the Mineral Rent(as % of GDP) of Natural Gas in 1983 and the Mineral Rent(as % of GDP) of Other Minerals in 1990?
Your answer should be very brief. -0.17. What is the difference between the Mineral Rent(as % of GDP) of Oil in 1983 and the Mineral Rent(as % of GDP) of Other Minerals in 1990?
Give a very brief answer. 1.93. What is the difference between the Mineral Rent(as % of GDP) of Coal in 1984 and the Mineral Rent(as % of GDP) of Natural Gas in 1985?
Offer a terse response. 0.51. What is the difference between the Mineral Rent(as % of GDP) of Coal in 1984 and the Mineral Rent(as % of GDP) of Oil in 1985?
Your answer should be compact. -1.48. What is the difference between the Mineral Rent(as % of GDP) in Coal in 1984 and the Mineral Rent(as % of GDP) in Other Minerals in 1985?
Keep it short and to the point. 0.42. What is the difference between the Mineral Rent(as % of GDP) in Natural Gas in 1984 and the Mineral Rent(as % of GDP) in Oil in 1985?
Give a very brief answer. -1.99. What is the difference between the Mineral Rent(as % of GDP) of Natural Gas in 1984 and the Mineral Rent(as % of GDP) of Other Minerals in 1985?
Make the answer very short. -0.1. What is the difference between the Mineral Rent(as % of GDP) of Oil in 1984 and the Mineral Rent(as % of GDP) of Other Minerals in 1985?
Keep it short and to the point. 2.21. What is the difference between the Mineral Rent(as % of GDP) in Coal in 1984 and the Mineral Rent(as % of GDP) in Natural Gas in 1986?
Give a very brief answer. 0.49. What is the difference between the Mineral Rent(as % of GDP) in Coal in 1984 and the Mineral Rent(as % of GDP) in Oil in 1986?
Offer a terse response. -0.23. What is the difference between the Mineral Rent(as % of GDP) of Coal in 1984 and the Mineral Rent(as % of GDP) of Other Minerals in 1986?
Your answer should be very brief. 0.43. What is the difference between the Mineral Rent(as % of GDP) in Natural Gas in 1984 and the Mineral Rent(as % of GDP) in Oil in 1986?
Your answer should be very brief. -0.75. What is the difference between the Mineral Rent(as % of GDP) in Natural Gas in 1984 and the Mineral Rent(as % of GDP) in Other Minerals in 1986?
Offer a very short reply. -0.09. What is the difference between the Mineral Rent(as % of GDP) in Oil in 1984 and the Mineral Rent(as % of GDP) in Other Minerals in 1986?
Keep it short and to the point. 2.22. What is the difference between the Mineral Rent(as % of GDP) of Coal in 1984 and the Mineral Rent(as % of GDP) of Natural Gas in 1987?
Provide a succinct answer. 0.54. What is the difference between the Mineral Rent(as % of GDP) in Coal in 1984 and the Mineral Rent(as % of GDP) in Oil in 1987?
Ensure brevity in your answer.  -0.47. What is the difference between the Mineral Rent(as % of GDP) of Coal in 1984 and the Mineral Rent(as % of GDP) of Other Minerals in 1987?
Offer a very short reply. 0.48. What is the difference between the Mineral Rent(as % of GDP) in Natural Gas in 1984 and the Mineral Rent(as % of GDP) in Oil in 1987?
Your answer should be compact. -0.98. What is the difference between the Mineral Rent(as % of GDP) in Natural Gas in 1984 and the Mineral Rent(as % of GDP) in Other Minerals in 1987?
Offer a very short reply. -0.04. What is the difference between the Mineral Rent(as % of GDP) of Oil in 1984 and the Mineral Rent(as % of GDP) of Other Minerals in 1987?
Make the answer very short. 2.26. What is the difference between the Mineral Rent(as % of GDP) in Coal in 1984 and the Mineral Rent(as % of GDP) in Natural Gas in 1988?
Make the answer very short. 0.54. What is the difference between the Mineral Rent(as % of GDP) in Coal in 1984 and the Mineral Rent(as % of GDP) in Oil in 1988?
Offer a very short reply. -0.18. What is the difference between the Mineral Rent(as % of GDP) of Coal in 1984 and the Mineral Rent(as % of GDP) of Other Minerals in 1988?
Provide a short and direct response. 0.41. What is the difference between the Mineral Rent(as % of GDP) in Natural Gas in 1984 and the Mineral Rent(as % of GDP) in Oil in 1988?
Give a very brief answer. -0.69. What is the difference between the Mineral Rent(as % of GDP) of Natural Gas in 1984 and the Mineral Rent(as % of GDP) of Other Minerals in 1988?
Offer a terse response. -0.1. What is the difference between the Mineral Rent(as % of GDP) of Oil in 1984 and the Mineral Rent(as % of GDP) of Other Minerals in 1988?
Provide a short and direct response. 2.2. What is the difference between the Mineral Rent(as % of GDP) in Coal in 1984 and the Mineral Rent(as % of GDP) in Natural Gas in 1989?
Keep it short and to the point. 0.53. What is the difference between the Mineral Rent(as % of GDP) of Coal in 1984 and the Mineral Rent(as % of GDP) of Oil in 1989?
Offer a terse response. -0.49. What is the difference between the Mineral Rent(as % of GDP) in Coal in 1984 and the Mineral Rent(as % of GDP) in Other Minerals in 1989?
Give a very brief answer. 0.35. What is the difference between the Mineral Rent(as % of GDP) in Natural Gas in 1984 and the Mineral Rent(as % of GDP) in Oil in 1989?
Make the answer very short. -1.01. What is the difference between the Mineral Rent(as % of GDP) in Natural Gas in 1984 and the Mineral Rent(as % of GDP) in Other Minerals in 1989?
Your response must be concise. -0.17. What is the difference between the Mineral Rent(as % of GDP) in Oil in 1984 and the Mineral Rent(as % of GDP) in Other Minerals in 1989?
Your answer should be compact. 2.14. What is the difference between the Mineral Rent(as % of GDP) in Coal in 1984 and the Mineral Rent(as % of GDP) in Natural Gas in 1990?
Your answer should be compact. 0.46. What is the difference between the Mineral Rent(as % of GDP) of Coal in 1984 and the Mineral Rent(as % of GDP) of Oil in 1990?
Ensure brevity in your answer.  -0.76. What is the difference between the Mineral Rent(as % of GDP) of Coal in 1984 and the Mineral Rent(as % of GDP) of Other Minerals in 1990?
Keep it short and to the point. 0.37. What is the difference between the Mineral Rent(as % of GDP) of Natural Gas in 1984 and the Mineral Rent(as % of GDP) of Oil in 1990?
Offer a very short reply. -1.28. What is the difference between the Mineral Rent(as % of GDP) in Natural Gas in 1984 and the Mineral Rent(as % of GDP) in Other Minerals in 1990?
Your response must be concise. -0.15. What is the difference between the Mineral Rent(as % of GDP) of Oil in 1984 and the Mineral Rent(as % of GDP) of Other Minerals in 1990?
Offer a terse response. 2.15. What is the difference between the Mineral Rent(as % of GDP) of Coal in 1985 and the Mineral Rent(as % of GDP) of Natural Gas in 1986?
Give a very brief answer. 0.57. What is the difference between the Mineral Rent(as % of GDP) in Coal in 1985 and the Mineral Rent(as % of GDP) in Oil in 1986?
Your answer should be very brief. -0.15. What is the difference between the Mineral Rent(as % of GDP) of Coal in 1985 and the Mineral Rent(as % of GDP) of Other Minerals in 1986?
Offer a terse response. 0.51. What is the difference between the Mineral Rent(as % of GDP) in Natural Gas in 1985 and the Mineral Rent(as % of GDP) in Oil in 1986?
Provide a succinct answer. -0.75. What is the difference between the Mineral Rent(as % of GDP) in Natural Gas in 1985 and the Mineral Rent(as % of GDP) in Other Minerals in 1986?
Ensure brevity in your answer.  -0.09. What is the difference between the Mineral Rent(as % of GDP) of Oil in 1985 and the Mineral Rent(as % of GDP) of Other Minerals in 1986?
Ensure brevity in your answer.  1.91. What is the difference between the Mineral Rent(as % of GDP) in Coal in 1985 and the Mineral Rent(as % of GDP) in Natural Gas in 1987?
Provide a succinct answer. 0.62. What is the difference between the Mineral Rent(as % of GDP) in Coal in 1985 and the Mineral Rent(as % of GDP) in Oil in 1987?
Your answer should be very brief. -0.38. What is the difference between the Mineral Rent(as % of GDP) of Coal in 1985 and the Mineral Rent(as % of GDP) of Other Minerals in 1987?
Your response must be concise. 0.56. What is the difference between the Mineral Rent(as % of GDP) in Natural Gas in 1985 and the Mineral Rent(as % of GDP) in Oil in 1987?
Your answer should be very brief. -0.98. What is the difference between the Mineral Rent(as % of GDP) in Natural Gas in 1985 and the Mineral Rent(as % of GDP) in Other Minerals in 1987?
Ensure brevity in your answer.  -0.04. What is the difference between the Mineral Rent(as % of GDP) in Oil in 1985 and the Mineral Rent(as % of GDP) in Other Minerals in 1987?
Offer a very short reply. 1.96. What is the difference between the Mineral Rent(as % of GDP) of Coal in 1985 and the Mineral Rent(as % of GDP) of Natural Gas in 1988?
Offer a terse response. 0.62. What is the difference between the Mineral Rent(as % of GDP) of Coal in 1985 and the Mineral Rent(as % of GDP) of Oil in 1988?
Offer a very short reply. -0.09. What is the difference between the Mineral Rent(as % of GDP) in Coal in 1985 and the Mineral Rent(as % of GDP) in Other Minerals in 1988?
Provide a succinct answer. 0.5. What is the difference between the Mineral Rent(as % of GDP) of Natural Gas in 1985 and the Mineral Rent(as % of GDP) of Oil in 1988?
Ensure brevity in your answer.  -0.69. What is the difference between the Mineral Rent(as % of GDP) in Natural Gas in 1985 and the Mineral Rent(as % of GDP) in Other Minerals in 1988?
Make the answer very short. -0.1. What is the difference between the Mineral Rent(as % of GDP) of Oil in 1985 and the Mineral Rent(as % of GDP) of Other Minerals in 1988?
Provide a short and direct response. 1.89. What is the difference between the Mineral Rent(as % of GDP) in Coal in 1985 and the Mineral Rent(as % of GDP) in Natural Gas in 1989?
Your answer should be very brief. 0.61. What is the difference between the Mineral Rent(as % of GDP) in Coal in 1985 and the Mineral Rent(as % of GDP) in Oil in 1989?
Make the answer very short. -0.41. What is the difference between the Mineral Rent(as % of GDP) of Coal in 1985 and the Mineral Rent(as % of GDP) of Other Minerals in 1989?
Provide a short and direct response. 0.43. What is the difference between the Mineral Rent(as % of GDP) in Natural Gas in 1985 and the Mineral Rent(as % of GDP) in Oil in 1989?
Provide a succinct answer. -1.01. What is the difference between the Mineral Rent(as % of GDP) of Natural Gas in 1985 and the Mineral Rent(as % of GDP) of Other Minerals in 1989?
Provide a succinct answer. -0.16. What is the difference between the Mineral Rent(as % of GDP) in Oil in 1985 and the Mineral Rent(as % of GDP) in Other Minerals in 1989?
Offer a terse response. 1.83. What is the difference between the Mineral Rent(as % of GDP) in Coal in 1985 and the Mineral Rent(as % of GDP) in Natural Gas in 1990?
Provide a short and direct response. 0.55. What is the difference between the Mineral Rent(as % of GDP) in Coal in 1985 and the Mineral Rent(as % of GDP) in Oil in 1990?
Offer a very short reply. -0.67. What is the difference between the Mineral Rent(as % of GDP) in Coal in 1985 and the Mineral Rent(as % of GDP) in Other Minerals in 1990?
Provide a short and direct response. 0.45. What is the difference between the Mineral Rent(as % of GDP) in Natural Gas in 1985 and the Mineral Rent(as % of GDP) in Oil in 1990?
Ensure brevity in your answer.  -1.27. What is the difference between the Mineral Rent(as % of GDP) of Natural Gas in 1985 and the Mineral Rent(as % of GDP) of Other Minerals in 1990?
Your response must be concise. -0.15. What is the difference between the Mineral Rent(as % of GDP) in Oil in 1985 and the Mineral Rent(as % of GDP) in Other Minerals in 1990?
Make the answer very short. 1.84. What is the difference between the Mineral Rent(as % of GDP) in Coal in 1986 and the Mineral Rent(as % of GDP) in Natural Gas in 1987?
Keep it short and to the point. 0.34. What is the difference between the Mineral Rent(as % of GDP) in Coal in 1986 and the Mineral Rent(as % of GDP) in Oil in 1987?
Your answer should be compact. -0.66. What is the difference between the Mineral Rent(as % of GDP) of Coal in 1986 and the Mineral Rent(as % of GDP) of Other Minerals in 1987?
Offer a very short reply. 0.28. What is the difference between the Mineral Rent(as % of GDP) of Natural Gas in 1986 and the Mineral Rent(as % of GDP) of Oil in 1987?
Your answer should be very brief. -0.95. What is the difference between the Mineral Rent(as % of GDP) in Natural Gas in 1986 and the Mineral Rent(as % of GDP) in Other Minerals in 1987?
Offer a very short reply. -0.01. What is the difference between the Mineral Rent(as % of GDP) in Oil in 1986 and the Mineral Rent(as % of GDP) in Other Minerals in 1987?
Keep it short and to the point. 0.71. What is the difference between the Mineral Rent(as % of GDP) of Coal in 1986 and the Mineral Rent(as % of GDP) of Natural Gas in 1988?
Offer a very short reply. 0.34. What is the difference between the Mineral Rent(as % of GDP) of Coal in 1986 and the Mineral Rent(as % of GDP) of Oil in 1988?
Your response must be concise. -0.37. What is the difference between the Mineral Rent(as % of GDP) in Coal in 1986 and the Mineral Rent(as % of GDP) in Other Minerals in 1988?
Ensure brevity in your answer.  0.22. What is the difference between the Mineral Rent(as % of GDP) of Natural Gas in 1986 and the Mineral Rent(as % of GDP) of Oil in 1988?
Offer a very short reply. -0.67. What is the difference between the Mineral Rent(as % of GDP) of Natural Gas in 1986 and the Mineral Rent(as % of GDP) of Other Minerals in 1988?
Ensure brevity in your answer.  -0.07. What is the difference between the Mineral Rent(as % of GDP) of Oil in 1986 and the Mineral Rent(as % of GDP) of Other Minerals in 1988?
Your response must be concise. 0.65. What is the difference between the Mineral Rent(as % of GDP) of Coal in 1986 and the Mineral Rent(as % of GDP) of Natural Gas in 1989?
Offer a terse response. 0.34. What is the difference between the Mineral Rent(as % of GDP) in Coal in 1986 and the Mineral Rent(as % of GDP) in Oil in 1989?
Provide a succinct answer. -0.69. What is the difference between the Mineral Rent(as % of GDP) of Coal in 1986 and the Mineral Rent(as % of GDP) of Other Minerals in 1989?
Provide a short and direct response. 0.16. What is the difference between the Mineral Rent(as % of GDP) of Natural Gas in 1986 and the Mineral Rent(as % of GDP) of Oil in 1989?
Your response must be concise. -0.98. What is the difference between the Mineral Rent(as % of GDP) in Natural Gas in 1986 and the Mineral Rent(as % of GDP) in Other Minerals in 1989?
Ensure brevity in your answer.  -0.14. What is the difference between the Mineral Rent(as % of GDP) of Oil in 1986 and the Mineral Rent(as % of GDP) of Other Minerals in 1989?
Make the answer very short. 0.58. What is the difference between the Mineral Rent(as % of GDP) of Coal in 1986 and the Mineral Rent(as % of GDP) of Natural Gas in 1990?
Provide a short and direct response. 0.27. What is the difference between the Mineral Rent(as % of GDP) of Coal in 1986 and the Mineral Rent(as % of GDP) of Oil in 1990?
Give a very brief answer. -0.95. What is the difference between the Mineral Rent(as % of GDP) of Coal in 1986 and the Mineral Rent(as % of GDP) of Other Minerals in 1990?
Your response must be concise. 0.17. What is the difference between the Mineral Rent(as % of GDP) of Natural Gas in 1986 and the Mineral Rent(as % of GDP) of Oil in 1990?
Make the answer very short. -1.25. What is the difference between the Mineral Rent(as % of GDP) of Natural Gas in 1986 and the Mineral Rent(as % of GDP) of Other Minerals in 1990?
Provide a succinct answer. -0.12. What is the difference between the Mineral Rent(as % of GDP) of Oil in 1986 and the Mineral Rent(as % of GDP) of Other Minerals in 1990?
Offer a very short reply. 0.6. What is the difference between the Mineral Rent(as % of GDP) in Coal in 1987 and the Mineral Rent(as % of GDP) in Natural Gas in 1988?
Offer a very short reply. 0.06. What is the difference between the Mineral Rent(as % of GDP) in Coal in 1987 and the Mineral Rent(as % of GDP) in Oil in 1988?
Keep it short and to the point. -0.65. What is the difference between the Mineral Rent(as % of GDP) in Coal in 1987 and the Mineral Rent(as % of GDP) in Other Minerals in 1988?
Your answer should be compact. -0.06. What is the difference between the Mineral Rent(as % of GDP) in Natural Gas in 1987 and the Mineral Rent(as % of GDP) in Oil in 1988?
Make the answer very short. -0.72. What is the difference between the Mineral Rent(as % of GDP) of Natural Gas in 1987 and the Mineral Rent(as % of GDP) of Other Minerals in 1988?
Your answer should be compact. -0.12. What is the difference between the Mineral Rent(as % of GDP) in Oil in 1987 and the Mineral Rent(as % of GDP) in Other Minerals in 1988?
Provide a short and direct response. 0.88. What is the difference between the Mineral Rent(as % of GDP) of Coal in 1987 and the Mineral Rent(as % of GDP) of Natural Gas in 1989?
Keep it short and to the point. 0.05. What is the difference between the Mineral Rent(as % of GDP) of Coal in 1987 and the Mineral Rent(as % of GDP) of Oil in 1989?
Ensure brevity in your answer.  -0.97. What is the difference between the Mineral Rent(as % of GDP) of Coal in 1987 and the Mineral Rent(as % of GDP) of Other Minerals in 1989?
Provide a short and direct response. -0.13. What is the difference between the Mineral Rent(as % of GDP) of Natural Gas in 1987 and the Mineral Rent(as % of GDP) of Oil in 1989?
Your answer should be very brief. -1.03. What is the difference between the Mineral Rent(as % of GDP) in Natural Gas in 1987 and the Mineral Rent(as % of GDP) in Other Minerals in 1989?
Offer a very short reply. -0.19. What is the difference between the Mineral Rent(as % of GDP) of Oil in 1987 and the Mineral Rent(as % of GDP) of Other Minerals in 1989?
Keep it short and to the point. 0.81. What is the difference between the Mineral Rent(as % of GDP) of Coal in 1987 and the Mineral Rent(as % of GDP) of Natural Gas in 1990?
Offer a very short reply. -0.01. What is the difference between the Mineral Rent(as % of GDP) in Coal in 1987 and the Mineral Rent(as % of GDP) in Oil in 1990?
Ensure brevity in your answer.  -1.24. What is the difference between the Mineral Rent(as % of GDP) of Coal in 1987 and the Mineral Rent(as % of GDP) of Other Minerals in 1990?
Your answer should be compact. -0.11. What is the difference between the Mineral Rent(as % of GDP) in Natural Gas in 1987 and the Mineral Rent(as % of GDP) in Oil in 1990?
Your response must be concise. -1.3. What is the difference between the Mineral Rent(as % of GDP) of Natural Gas in 1987 and the Mineral Rent(as % of GDP) of Other Minerals in 1990?
Offer a very short reply. -0.17. What is the difference between the Mineral Rent(as % of GDP) in Oil in 1987 and the Mineral Rent(as % of GDP) in Other Minerals in 1990?
Keep it short and to the point. 0.83. What is the difference between the Mineral Rent(as % of GDP) of Coal in 1988 and the Mineral Rent(as % of GDP) of Natural Gas in 1989?
Ensure brevity in your answer.  0.19. What is the difference between the Mineral Rent(as % of GDP) in Coal in 1988 and the Mineral Rent(as % of GDP) in Oil in 1989?
Make the answer very short. -0.83. What is the difference between the Mineral Rent(as % of GDP) of Coal in 1988 and the Mineral Rent(as % of GDP) of Other Minerals in 1989?
Your answer should be compact. 0.01. What is the difference between the Mineral Rent(as % of GDP) of Natural Gas in 1988 and the Mineral Rent(as % of GDP) of Oil in 1989?
Offer a terse response. -1.03. What is the difference between the Mineral Rent(as % of GDP) of Natural Gas in 1988 and the Mineral Rent(as % of GDP) of Other Minerals in 1989?
Offer a terse response. -0.19. What is the difference between the Mineral Rent(as % of GDP) in Oil in 1988 and the Mineral Rent(as % of GDP) in Other Minerals in 1989?
Make the answer very short. 0.53. What is the difference between the Mineral Rent(as % of GDP) in Coal in 1988 and the Mineral Rent(as % of GDP) in Natural Gas in 1990?
Make the answer very short. 0.13. What is the difference between the Mineral Rent(as % of GDP) of Coal in 1988 and the Mineral Rent(as % of GDP) of Oil in 1990?
Provide a succinct answer. -1.1. What is the difference between the Mineral Rent(as % of GDP) in Coal in 1988 and the Mineral Rent(as % of GDP) in Other Minerals in 1990?
Your answer should be very brief. 0.03. What is the difference between the Mineral Rent(as % of GDP) of Natural Gas in 1988 and the Mineral Rent(as % of GDP) of Oil in 1990?
Offer a very short reply. -1.3. What is the difference between the Mineral Rent(as % of GDP) of Natural Gas in 1988 and the Mineral Rent(as % of GDP) of Other Minerals in 1990?
Provide a short and direct response. -0.17. What is the difference between the Mineral Rent(as % of GDP) in Oil in 1988 and the Mineral Rent(as % of GDP) in Other Minerals in 1990?
Give a very brief answer. 0.54. What is the difference between the Mineral Rent(as % of GDP) of Coal in 1989 and the Mineral Rent(as % of GDP) of Natural Gas in 1990?
Keep it short and to the point. 0.29. What is the difference between the Mineral Rent(as % of GDP) in Coal in 1989 and the Mineral Rent(as % of GDP) in Oil in 1990?
Provide a short and direct response. -0.93. What is the difference between the Mineral Rent(as % of GDP) of Coal in 1989 and the Mineral Rent(as % of GDP) of Other Minerals in 1990?
Provide a succinct answer. 0.19. What is the difference between the Mineral Rent(as % of GDP) in Natural Gas in 1989 and the Mineral Rent(as % of GDP) in Oil in 1990?
Keep it short and to the point. -1.29. What is the difference between the Mineral Rent(as % of GDP) in Natural Gas in 1989 and the Mineral Rent(as % of GDP) in Other Minerals in 1990?
Provide a short and direct response. -0.16. What is the difference between the Mineral Rent(as % of GDP) of Oil in 1989 and the Mineral Rent(as % of GDP) of Other Minerals in 1990?
Your answer should be compact. 0.86. What is the average Mineral Rent(as % of GDP) of Coal per year?
Offer a very short reply. 0.64. What is the average Mineral Rent(as % of GDP) in Natural Gas per year?
Your answer should be compact. 0.15. What is the average Mineral Rent(as % of GDP) of Oil per year?
Keep it short and to the point. 1.61. What is the average Mineral Rent(as % of GDP) of Other Minerals per year?
Ensure brevity in your answer.  0.26. In the year 1982, what is the difference between the Mineral Rent(as % of GDP) in Coal and Mineral Rent(as % of GDP) in Natural Gas?
Offer a very short reply. 1.42. In the year 1982, what is the difference between the Mineral Rent(as % of GDP) of Coal and Mineral Rent(as % of GDP) of Oil?
Offer a terse response. -0.67. In the year 1982, what is the difference between the Mineral Rent(as % of GDP) of Coal and Mineral Rent(as % of GDP) of Other Minerals?
Keep it short and to the point. 1.21. In the year 1982, what is the difference between the Mineral Rent(as % of GDP) of Natural Gas and Mineral Rent(as % of GDP) of Oil?
Keep it short and to the point. -2.09. In the year 1982, what is the difference between the Mineral Rent(as % of GDP) of Natural Gas and Mineral Rent(as % of GDP) of Other Minerals?
Your response must be concise. -0.21. In the year 1982, what is the difference between the Mineral Rent(as % of GDP) in Oil and Mineral Rent(as % of GDP) in Other Minerals?
Your answer should be compact. 1.88. In the year 1983, what is the difference between the Mineral Rent(as % of GDP) of Coal and Mineral Rent(as % of GDP) of Natural Gas?
Ensure brevity in your answer.  0.68. In the year 1983, what is the difference between the Mineral Rent(as % of GDP) of Coal and Mineral Rent(as % of GDP) of Oil?
Provide a succinct answer. -1.42. In the year 1983, what is the difference between the Mineral Rent(as % of GDP) of Coal and Mineral Rent(as % of GDP) of Other Minerals?
Ensure brevity in your answer.  0.56. In the year 1983, what is the difference between the Mineral Rent(as % of GDP) in Natural Gas and Mineral Rent(as % of GDP) in Oil?
Offer a terse response. -2.1. In the year 1983, what is the difference between the Mineral Rent(as % of GDP) of Natural Gas and Mineral Rent(as % of GDP) of Other Minerals?
Your answer should be compact. -0.12. In the year 1983, what is the difference between the Mineral Rent(as % of GDP) in Oil and Mineral Rent(as % of GDP) in Other Minerals?
Provide a short and direct response. 1.98. In the year 1984, what is the difference between the Mineral Rent(as % of GDP) of Coal and Mineral Rent(as % of GDP) of Natural Gas?
Offer a terse response. 0.51. In the year 1984, what is the difference between the Mineral Rent(as % of GDP) of Coal and Mineral Rent(as % of GDP) of Oil?
Make the answer very short. -1.79. In the year 1984, what is the difference between the Mineral Rent(as % of GDP) of Coal and Mineral Rent(as % of GDP) of Other Minerals?
Offer a terse response. 0.41. In the year 1984, what is the difference between the Mineral Rent(as % of GDP) of Natural Gas and Mineral Rent(as % of GDP) of Oil?
Your answer should be very brief. -2.3. In the year 1984, what is the difference between the Mineral Rent(as % of GDP) in Natural Gas and Mineral Rent(as % of GDP) in Other Minerals?
Provide a short and direct response. -0.1. In the year 1984, what is the difference between the Mineral Rent(as % of GDP) in Oil and Mineral Rent(as % of GDP) in Other Minerals?
Ensure brevity in your answer.  2.2. In the year 1985, what is the difference between the Mineral Rent(as % of GDP) of Coal and Mineral Rent(as % of GDP) of Natural Gas?
Keep it short and to the point. 0.6. In the year 1985, what is the difference between the Mineral Rent(as % of GDP) of Coal and Mineral Rent(as % of GDP) of Oil?
Your response must be concise. -1.39. In the year 1985, what is the difference between the Mineral Rent(as % of GDP) in Coal and Mineral Rent(as % of GDP) in Other Minerals?
Your response must be concise. 0.5. In the year 1985, what is the difference between the Mineral Rent(as % of GDP) of Natural Gas and Mineral Rent(as % of GDP) of Oil?
Your response must be concise. -1.99. In the year 1985, what is the difference between the Mineral Rent(as % of GDP) in Natural Gas and Mineral Rent(as % of GDP) in Other Minerals?
Provide a short and direct response. -0.1. In the year 1985, what is the difference between the Mineral Rent(as % of GDP) of Oil and Mineral Rent(as % of GDP) of Other Minerals?
Offer a very short reply. 1.9. In the year 1986, what is the difference between the Mineral Rent(as % of GDP) in Coal and Mineral Rent(as % of GDP) in Natural Gas?
Your response must be concise. 0.29. In the year 1986, what is the difference between the Mineral Rent(as % of GDP) in Coal and Mineral Rent(as % of GDP) in Oil?
Offer a terse response. -0.43. In the year 1986, what is the difference between the Mineral Rent(as % of GDP) in Coal and Mineral Rent(as % of GDP) in Other Minerals?
Your answer should be very brief. 0.24. In the year 1986, what is the difference between the Mineral Rent(as % of GDP) of Natural Gas and Mineral Rent(as % of GDP) of Oil?
Offer a very short reply. -0.72. In the year 1986, what is the difference between the Mineral Rent(as % of GDP) in Natural Gas and Mineral Rent(as % of GDP) in Other Minerals?
Offer a terse response. -0.06. In the year 1986, what is the difference between the Mineral Rent(as % of GDP) in Oil and Mineral Rent(as % of GDP) in Other Minerals?
Your answer should be compact. 0.66. In the year 1987, what is the difference between the Mineral Rent(as % of GDP) of Coal and Mineral Rent(as % of GDP) of Natural Gas?
Provide a short and direct response. 0.06. In the year 1987, what is the difference between the Mineral Rent(as % of GDP) in Coal and Mineral Rent(as % of GDP) in Oil?
Offer a terse response. -0.94. In the year 1987, what is the difference between the Mineral Rent(as % of GDP) of Coal and Mineral Rent(as % of GDP) of Other Minerals?
Offer a very short reply. -0. In the year 1987, what is the difference between the Mineral Rent(as % of GDP) of Natural Gas and Mineral Rent(as % of GDP) of Oil?
Your answer should be very brief. -1. In the year 1987, what is the difference between the Mineral Rent(as % of GDP) of Natural Gas and Mineral Rent(as % of GDP) of Other Minerals?
Your answer should be compact. -0.06. In the year 1987, what is the difference between the Mineral Rent(as % of GDP) in Oil and Mineral Rent(as % of GDP) in Other Minerals?
Make the answer very short. 0.94. In the year 1988, what is the difference between the Mineral Rent(as % of GDP) in Coal and Mineral Rent(as % of GDP) in Natural Gas?
Ensure brevity in your answer.  0.2. In the year 1988, what is the difference between the Mineral Rent(as % of GDP) of Coal and Mineral Rent(as % of GDP) of Oil?
Provide a short and direct response. -0.51. In the year 1988, what is the difference between the Mineral Rent(as % of GDP) in Coal and Mineral Rent(as % of GDP) in Other Minerals?
Ensure brevity in your answer.  0.08. In the year 1988, what is the difference between the Mineral Rent(as % of GDP) in Natural Gas and Mineral Rent(as % of GDP) in Oil?
Your answer should be very brief. -0.71. In the year 1988, what is the difference between the Mineral Rent(as % of GDP) of Natural Gas and Mineral Rent(as % of GDP) of Other Minerals?
Keep it short and to the point. -0.12. In the year 1988, what is the difference between the Mineral Rent(as % of GDP) of Oil and Mineral Rent(as % of GDP) of Other Minerals?
Your response must be concise. 0.59. In the year 1989, what is the difference between the Mineral Rent(as % of GDP) in Coal and Mineral Rent(as % of GDP) in Natural Gas?
Provide a succinct answer. 0.36. In the year 1989, what is the difference between the Mineral Rent(as % of GDP) of Coal and Mineral Rent(as % of GDP) of Oil?
Provide a short and direct response. -0.66. In the year 1989, what is the difference between the Mineral Rent(as % of GDP) in Coal and Mineral Rent(as % of GDP) in Other Minerals?
Your response must be concise. 0.18. In the year 1989, what is the difference between the Mineral Rent(as % of GDP) in Natural Gas and Mineral Rent(as % of GDP) in Oil?
Ensure brevity in your answer.  -1.02. In the year 1989, what is the difference between the Mineral Rent(as % of GDP) of Natural Gas and Mineral Rent(as % of GDP) of Other Minerals?
Offer a terse response. -0.18. In the year 1989, what is the difference between the Mineral Rent(as % of GDP) of Oil and Mineral Rent(as % of GDP) of Other Minerals?
Make the answer very short. 0.84. In the year 1990, what is the difference between the Mineral Rent(as % of GDP) of Coal and Mineral Rent(as % of GDP) of Natural Gas?
Make the answer very short. 0.33. In the year 1990, what is the difference between the Mineral Rent(as % of GDP) in Coal and Mineral Rent(as % of GDP) in Oil?
Your answer should be compact. -0.9. In the year 1990, what is the difference between the Mineral Rent(as % of GDP) in Coal and Mineral Rent(as % of GDP) in Other Minerals?
Your response must be concise. 0.23. In the year 1990, what is the difference between the Mineral Rent(as % of GDP) in Natural Gas and Mineral Rent(as % of GDP) in Oil?
Provide a short and direct response. -1.22. In the year 1990, what is the difference between the Mineral Rent(as % of GDP) of Natural Gas and Mineral Rent(as % of GDP) of Other Minerals?
Make the answer very short. -0.1. In the year 1990, what is the difference between the Mineral Rent(as % of GDP) of Oil and Mineral Rent(as % of GDP) of Other Minerals?
Offer a terse response. 1.13. What is the ratio of the Mineral Rent(as % of GDP) in Coal in 1982 to that in 1983?
Keep it short and to the point. 1.91. What is the ratio of the Mineral Rent(as % of GDP) in Natural Gas in 1982 to that in 1983?
Keep it short and to the point. 0.98. What is the ratio of the Mineral Rent(as % of GDP) in Other Minerals in 1982 to that in 1983?
Provide a succinct answer. 1.38. What is the ratio of the Mineral Rent(as % of GDP) in Coal in 1982 to that in 1984?
Provide a short and direct response. 2.33. What is the ratio of the Mineral Rent(as % of GDP) of Natural Gas in 1982 to that in 1984?
Make the answer very short. 0.87. What is the ratio of the Mineral Rent(as % of GDP) of Oil in 1982 to that in 1984?
Keep it short and to the point. 0.91. What is the ratio of the Mineral Rent(as % of GDP) of Other Minerals in 1982 to that in 1984?
Keep it short and to the point. 1.37. What is the ratio of the Mineral Rent(as % of GDP) in Coal in 1982 to that in 1985?
Keep it short and to the point. 2.07. What is the ratio of the Mineral Rent(as % of GDP) in Natural Gas in 1982 to that in 1985?
Provide a succinct answer. 0.86. What is the ratio of the Mineral Rent(as % of GDP) in Oil in 1982 to that in 1985?
Your answer should be compact. 1.04. What is the ratio of the Mineral Rent(as % of GDP) of Other Minerals in 1982 to that in 1985?
Offer a terse response. 1.39. What is the ratio of the Mineral Rent(as % of GDP) of Coal in 1982 to that in 1986?
Provide a short and direct response. 3.29. What is the ratio of the Mineral Rent(as % of GDP) in Natural Gas in 1982 to that in 1986?
Offer a terse response. 0.74. What is the ratio of the Mineral Rent(as % of GDP) of Oil in 1982 to that in 1986?
Offer a terse response. 2.47. What is the ratio of the Mineral Rent(as % of GDP) of Other Minerals in 1982 to that in 1986?
Make the answer very short. 1.45. What is the ratio of the Mineral Rent(as % of GDP) of Coal in 1982 to that in 1987?
Offer a very short reply. 8.27. What is the ratio of the Mineral Rent(as % of GDP) of Natural Gas in 1982 to that in 1987?
Give a very brief answer. 1.03. What is the ratio of the Mineral Rent(as % of GDP) of Oil in 1982 to that in 1987?
Provide a succinct answer. 1.96. What is the ratio of the Mineral Rent(as % of GDP) of Other Minerals in 1982 to that in 1987?
Make the answer very short. 1.82. What is the ratio of the Mineral Rent(as % of GDP) in Coal in 1982 to that in 1988?
Offer a very short reply. 4.71. What is the ratio of the Mineral Rent(as % of GDP) of Natural Gas in 1982 to that in 1988?
Keep it short and to the point. 1.02. What is the ratio of the Mineral Rent(as % of GDP) of Oil in 1982 to that in 1988?
Provide a short and direct response. 2.63. What is the ratio of the Mineral Rent(as % of GDP) in Other Minerals in 1982 to that in 1988?
Offer a very short reply. 1.37. What is the ratio of the Mineral Rent(as % of GDP) of Coal in 1982 to that in 1989?
Offer a very short reply. 3.15. What is the ratio of the Mineral Rent(as % of GDP) of Natural Gas in 1982 to that in 1989?
Your answer should be very brief. 0.96. What is the ratio of the Mineral Rent(as % of GDP) in Oil in 1982 to that in 1989?
Your answer should be very brief. 1.92. What is the ratio of the Mineral Rent(as % of GDP) in Other Minerals in 1982 to that in 1989?
Provide a short and direct response. 1.09. What is the ratio of the Mineral Rent(as % of GDP) in Coal in 1982 to that in 1990?
Your response must be concise. 2.94. What is the ratio of the Mineral Rent(as % of GDP) in Natural Gas in 1982 to that in 1990?
Provide a succinct answer. 0.65. What is the ratio of the Mineral Rent(as % of GDP) of Oil in 1982 to that in 1990?
Provide a succinct answer. 1.56. What is the ratio of the Mineral Rent(as % of GDP) of Other Minerals in 1982 to that in 1990?
Provide a succinct answer. 1.15. What is the ratio of the Mineral Rent(as % of GDP) in Coal in 1983 to that in 1984?
Keep it short and to the point. 1.22. What is the ratio of the Mineral Rent(as % of GDP) of Natural Gas in 1983 to that in 1984?
Give a very brief answer. 0.89. What is the ratio of the Mineral Rent(as % of GDP) of Oil in 1983 to that in 1984?
Offer a terse response. 0.91. What is the ratio of the Mineral Rent(as % of GDP) of Other Minerals in 1983 to that in 1984?
Your response must be concise. 0.99. What is the ratio of the Mineral Rent(as % of GDP) of Coal in 1983 to that in 1985?
Provide a short and direct response. 1.08. What is the ratio of the Mineral Rent(as % of GDP) of Natural Gas in 1983 to that in 1985?
Provide a short and direct response. 0.88. What is the ratio of the Mineral Rent(as % of GDP) in Oil in 1983 to that in 1985?
Your answer should be very brief. 1.04. What is the ratio of the Mineral Rent(as % of GDP) in Coal in 1983 to that in 1986?
Your answer should be very brief. 1.72. What is the ratio of the Mineral Rent(as % of GDP) of Natural Gas in 1983 to that in 1986?
Provide a succinct answer. 0.75. What is the ratio of the Mineral Rent(as % of GDP) of Oil in 1983 to that in 1986?
Offer a very short reply. 2.48. What is the ratio of the Mineral Rent(as % of GDP) in Other Minerals in 1983 to that in 1986?
Your answer should be very brief. 1.05. What is the ratio of the Mineral Rent(as % of GDP) of Coal in 1983 to that in 1987?
Provide a short and direct response. 4.33. What is the ratio of the Mineral Rent(as % of GDP) in Natural Gas in 1983 to that in 1987?
Ensure brevity in your answer.  1.04. What is the ratio of the Mineral Rent(as % of GDP) in Oil in 1983 to that in 1987?
Your answer should be compact. 1.98. What is the ratio of the Mineral Rent(as % of GDP) in Other Minerals in 1983 to that in 1987?
Your answer should be very brief. 1.32. What is the ratio of the Mineral Rent(as % of GDP) in Coal in 1983 to that in 1988?
Offer a terse response. 2.46. What is the ratio of the Mineral Rent(as % of GDP) in Natural Gas in 1983 to that in 1988?
Provide a short and direct response. 1.04. What is the ratio of the Mineral Rent(as % of GDP) of Oil in 1983 to that in 1988?
Offer a terse response. 2.65. What is the ratio of the Mineral Rent(as % of GDP) in Other Minerals in 1983 to that in 1988?
Give a very brief answer. 0.99. What is the ratio of the Mineral Rent(as % of GDP) in Coal in 1983 to that in 1989?
Your response must be concise. 1.65. What is the ratio of the Mineral Rent(as % of GDP) in Natural Gas in 1983 to that in 1989?
Provide a succinct answer. 0.98. What is the ratio of the Mineral Rent(as % of GDP) in Oil in 1983 to that in 1989?
Provide a succinct answer. 1.93. What is the ratio of the Mineral Rent(as % of GDP) in Other Minerals in 1983 to that in 1989?
Provide a succinct answer. 0.79. What is the ratio of the Mineral Rent(as % of GDP) of Coal in 1983 to that in 1990?
Give a very brief answer. 1.54. What is the ratio of the Mineral Rent(as % of GDP) of Natural Gas in 1983 to that in 1990?
Make the answer very short. 0.66. What is the ratio of the Mineral Rent(as % of GDP) of Oil in 1983 to that in 1990?
Make the answer very short. 1.57. What is the ratio of the Mineral Rent(as % of GDP) in Other Minerals in 1983 to that in 1990?
Your response must be concise. 0.83. What is the ratio of the Mineral Rent(as % of GDP) in Coal in 1984 to that in 1985?
Ensure brevity in your answer.  0.89. What is the ratio of the Mineral Rent(as % of GDP) of Natural Gas in 1984 to that in 1985?
Provide a short and direct response. 0.99. What is the ratio of the Mineral Rent(as % of GDP) of Oil in 1984 to that in 1985?
Give a very brief answer. 1.14. What is the ratio of the Mineral Rent(as % of GDP) in Other Minerals in 1984 to that in 1985?
Ensure brevity in your answer.  1.02. What is the ratio of the Mineral Rent(as % of GDP) in Coal in 1984 to that in 1986?
Your answer should be very brief. 1.41. What is the ratio of the Mineral Rent(as % of GDP) of Natural Gas in 1984 to that in 1986?
Ensure brevity in your answer.  0.85. What is the ratio of the Mineral Rent(as % of GDP) of Oil in 1984 to that in 1986?
Offer a very short reply. 2.73. What is the ratio of the Mineral Rent(as % of GDP) of Other Minerals in 1984 to that in 1986?
Your answer should be compact. 1.06. What is the ratio of the Mineral Rent(as % of GDP) of Coal in 1984 to that in 1987?
Provide a succinct answer. 3.55. What is the ratio of the Mineral Rent(as % of GDP) in Natural Gas in 1984 to that in 1987?
Your response must be concise. 1.18. What is the ratio of the Mineral Rent(as % of GDP) in Oil in 1984 to that in 1987?
Your response must be concise. 2.17. What is the ratio of the Mineral Rent(as % of GDP) in Other Minerals in 1984 to that in 1987?
Your answer should be very brief. 1.34. What is the ratio of the Mineral Rent(as % of GDP) in Coal in 1984 to that in 1988?
Your response must be concise. 2.02. What is the ratio of the Mineral Rent(as % of GDP) in Natural Gas in 1984 to that in 1988?
Ensure brevity in your answer.  1.18. What is the ratio of the Mineral Rent(as % of GDP) in Oil in 1984 to that in 1988?
Offer a terse response. 2.91. What is the ratio of the Mineral Rent(as % of GDP) in Coal in 1984 to that in 1989?
Offer a terse response. 1.35. What is the ratio of the Mineral Rent(as % of GDP) of Natural Gas in 1984 to that in 1989?
Provide a succinct answer. 1.1. What is the ratio of the Mineral Rent(as % of GDP) in Oil in 1984 to that in 1989?
Your response must be concise. 2.12. What is the ratio of the Mineral Rent(as % of GDP) in Other Minerals in 1984 to that in 1989?
Offer a very short reply. 0.8. What is the ratio of the Mineral Rent(as % of GDP) in Coal in 1984 to that in 1990?
Give a very brief answer. 1.26. What is the ratio of the Mineral Rent(as % of GDP) of Natural Gas in 1984 to that in 1990?
Provide a succinct answer. 0.74. What is the ratio of the Mineral Rent(as % of GDP) of Oil in 1984 to that in 1990?
Your response must be concise. 1.72. What is the ratio of the Mineral Rent(as % of GDP) of Other Minerals in 1984 to that in 1990?
Make the answer very short. 0.84. What is the ratio of the Mineral Rent(as % of GDP) in Coal in 1985 to that in 1986?
Your answer should be compact. 1.59. What is the ratio of the Mineral Rent(as % of GDP) of Natural Gas in 1985 to that in 1986?
Your response must be concise. 0.86. What is the ratio of the Mineral Rent(as % of GDP) of Oil in 1985 to that in 1986?
Provide a short and direct response. 2.38. What is the ratio of the Mineral Rent(as % of GDP) in Other Minerals in 1985 to that in 1986?
Offer a very short reply. 1.04. What is the ratio of the Mineral Rent(as % of GDP) in Coal in 1985 to that in 1987?
Offer a very short reply. 4. What is the ratio of the Mineral Rent(as % of GDP) of Natural Gas in 1985 to that in 1987?
Give a very brief answer. 1.19. What is the ratio of the Mineral Rent(as % of GDP) in Oil in 1985 to that in 1987?
Provide a short and direct response. 1.9. What is the ratio of the Mineral Rent(as % of GDP) in Other Minerals in 1985 to that in 1987?
Your answer should be very brief. 1.31. What is the ratio of the Mineral Rent(as % of GDP) in Coal in 1985 to that in 1988?
Offer a very short reply. 2.28. What is the ratio of the Mineral Rent(as % of GDP) in Natural Gas in 1985 to that in 1988?
Ensure brevity in your answer.  1.19. What is the ratio of the Mineral Rent(as % of GDP) of Oil in 1985 to that in 1988?
Your answer should be very brief. 2.55. What is the ratio of the Mineral Rent(as % of GDP) of Other Minerals in 1985 to that in 1988?
Ensure brevity in your answer.  0.99. What is the ratio of the Mineral Rent(as % of GDP) of Coal in 1985 to that in 1989?
Offer a very short reply. 1.52. What is the ratio of the Mineral Rent(as % of GDP) of Natural Gas in 1985 to that in 1989?
Make the answer very short. 1.12. What is the ratio of the Mineral Rent(as % of GDP) of Oil in 1985 to that in 1989?
Offer a terse response. 1.85. What is the ratio of the Mineral Rent(as % of GDP) of Other Minerals in 1985 to that in 1989?
Keep it short and to the point. 0.78. What is the ratio of the Mineral Rent(as % of GDP) of Coal in 1985 to that in 1990?
Your answer should be compact. 1.42. What is the ratio of the Mineral Rent(as % of GDP) in Natural Gas in 1985 to that in 1990?
Provide a short and direct response. 0.75. What is the ratio of the Mineral Rent(as % of GDP) of Oil in 1985 to that in 1990?
Give a very brief answer. 1.5. What is the ratio of the Mineral Rent(as % of GDP) of Other Minerals in 1985 to that in 1990?
Your response must be concise. 0.82. What is the ratio of the Mineral Rent(as % of GDP) of Coal in 1986 to that in 1987?
Your response must be concise. 2.52. What is the ratio of the Mineral Rent(as % of GDP) of Natural Gas in 1986 to that in 1987?
Offer a very short reply. 1.39. What is the ratio of the Mineral Rent(as % of GDP) of Oil in 1986 to that in 1987?
Your answer should be very brief. 0.8. What is the ratio of the Mineral Rent(as % of GDP) in Other Minerals in 1986 to that in 1987?
Your answer should be compact. 1.26. What is the ratio of the Mineral Rent(as % of GDP) of Coal in 1986 to that in 1988?
Your answer should be very brief. 1.43. What is the ratio of the Mineral Rent(as % of GDP) of Natural Gas in 1986 to that in 1988?
Provide a short and direct response. 1.39. What is the ratio of the Mineral Rent(as % of GDP) in Oil in 1986 to that in 1988?
Keep it short and to the point. 1.07. What is the ratio of the Mineral Rent(as % of GDP) in Other Minerals in 1986 to that in 1988?
Your answer should be compact. 0.94. What is the ratio of the Mineral Rent(as % of GDP) in Coal in 1986 to that in 1989?
Your answer should be very brief. 0.96. What is the ratio of the Mineral Rent(as % of GDP) in Natural Gas in 1986 to that in 1989?
Ensure brevity in your answer.  1.3. What is the ratio of the Mineral Rent(as % of GDP) in Oil in 1986 to that in 1989?
Ensure brevity in your answer.  0.78. What is the ratio of the Mineral Rent(as % of GDP) in Other Minerals in 1986 to that in 1989?
Ensure brevity in your answer.  0.75. What is the ratio of the Mineral Rent(as % of GDP) in Coal in 1986 to that in 1990?
Keep it short and to the point. 0.9. What is the ratio of the Mineral Rent(as % of GDP) of Natural Gas in 1986 to that in 1990?
Keep it short and to the point. 0.88. What is the ratio of the Mineral Rent(as % of GDP) in Oil in 1986 to that in 1990?
Your response must be concise. 0.63. What is the ratio of the Mineral Rent(as % of GDP) of Other Minerals in 1986 to that in 1990?
Provide a succinct answer. 0.79. What is the ratio of the Mineral Rent(as % of GDP) in Coal in 1987 to that in 1988?
Your response must be concise. 0.57. What is the ratio of the Mineral Rent(as % of GDP) of Oil in 1987 to that in 1988?
Provide a succinct answer. 1.34. What is the ratio of the Mineral Rent(as % of GDP) in Other Minerals in 1987 to that in 1988?
Give a very brief answer. 0.75. What is the ratio of the Mineral Rent(as % of GDP) of Coal in 1987 to that in 1989?
Offer a terse response. 0.38. What is the ratio of the Mineral Rent(as % of GDP) in Natural Gas in 1987 to that in 1989?
Make the answer very short. 0.94. What is the ratio of the Mineral Rent(as % of GDP) in Oil in 1987 to that in 1989?
Your response must be concise. 0.98. What is the ratio of the Mineral Rent(as % of GDP) of Other Minerals in 1987 to that in 1989?
Keep it short and to the point. 0.6. What is the ratio of the Mineral Rent(as % of GDP) in Coal in 1987 to that in 1990?
Your answer should be compact. 0.36. What is the ratio of the Mineral Rent(as % of GDP) in Natural Gas in 1987 to that in 1990?
Provide a short and direct response. 0.63. What is the ratio of the Mineral Rent(as % of GDP) in Oil in 1987 to that in 1990?
Provide a succinct answer. 0.79. What is the ratio of the Mineral Rent(as % of GDP) of Other Minerals in 1987 to that in 1990?
Keep it short and to the point. 0.63. What is the ratio of the Mineral Rent(as % of GDP) in Coal in 1988 to that in 1989?
Give a very brief answer. 0.67. What is the ratio of the Mineral Rent(as % of GDP) in Natural Gas in 1988 to that in 1989?
Give a very brief answer. 0.94. What is the ratio of the Mineral Rent(as % of GDP) in Oil in 1988 to that in 1989?
Ensure brevity in your answer.  0.73. What is the ratio of the Mineral Rent(as % of GDP) of Other Minerals in 1988 to that in 1989?
Keep it short and to the point. 0.79. What is the ratio of the Mineral Rent(as % of GDP) in Natural Gas in 1988 to that in 1990?
Make the answer very short. 0.63. What is the ratio of the Mineral Rent(as % of GDP) of Oil in 1988 to that in 1990?
Your response must be concise. 0.59. What is the ratio of the Mineral Rent(as % of GDP) of Other Minerals in 1988 to that in 1990?
Ensure brevity in your answer.  0.84. What is the ratio of the Mineral Rent(as % of GDP) of Coal in 1989 to that in 1990?
Make the answer very short. 0.93. What is the ratio of the Mineral Rent(as % of GDP) in Natural Gas in 1989 to that in 1990?
Give a very brief answer. 0.67. What is the ratio of the Mineral Rent(as % of GDP) in Oil in 1989 to that in 1990?
Your answer should be compact. 0.81. What is the ratio of the Mineral Rent(as % of GDP) in Other Minerals in 1989 to that in 1990?
Provide a succinct answer. 1.06. What is the difference between the highest and the second highest Mineral Rent(as % of GDP) of Coal?
Your answer should be compact. 0.74. What is the difference between the highest and the second highest Mineral Rent(as % of GDP) in Natural Gas?
Your answer should be very brief. 0.03. What is the difference between the highest and the second highest Mineral Rent(as % of GDP) in Oil?
Provide a short and direct response. 0.22. What is the difference between the highest and the second highest Mineral Rent(as % of GDP) in Other Minerals?
Give a very brief answer. 0.03. What is the difference between the highest and the lowest Mineral Rent(as % of GDP) in Coal?
Offer a terse response. 1.36. What is the difference between the highest and the lowest Mineral Rent(as % of GDP) in Natural Gas?
Make the answer very short. 0.07. What is the difference between the highest and the lowest Mineral Rent(as % of GDP) in Oil?
Your answer should be compact. 1.61. What is the difference between the highest and the lowest Mineral Rent(as % of GDP) of Other Minerals?
Your answer should be very brief. 0.16. 